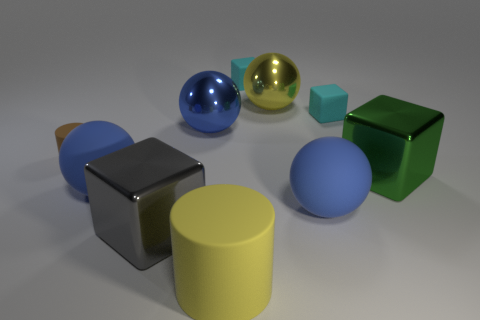Does the big metallic sphere on the right side of the large cylinder have the same color as the large cylinder?
Make the answer very short. Yes. What is the color of the cylinder that is the same size as the green object?
Give a very brief answer. Yellow. Are there any yellow matte things that have the same shape as the tiny brown object?
Provide a short and direct response. Yes. There is a yellow sphere that is to the right of the blue ball behind the cylinder left of the large matte cylinder; what is it made of?
Offer a very short reply. Metal. How many other things are there of the same size as the green metallic block?
Ensure brevity in your answer.  6. The big cylinder is what color?
Offer a very short reply. Yellow. How many matte objects are either small brown objects or cyan things?
Your answer should be compact. 3. Are there any other things that have the same material as the big cylinder?
Your answer should be compact. Yes. What size is the cyan block to the left of the tiny cyan matte thing that is to the right of the blue sphere that is to the right of the big yellow cylinder?
Provide a succinct answer. Small. How big is the shiny object that is both on the left side of the large green metal object and to the right of the large cylinder?
Your answer should be very brief. Large. 